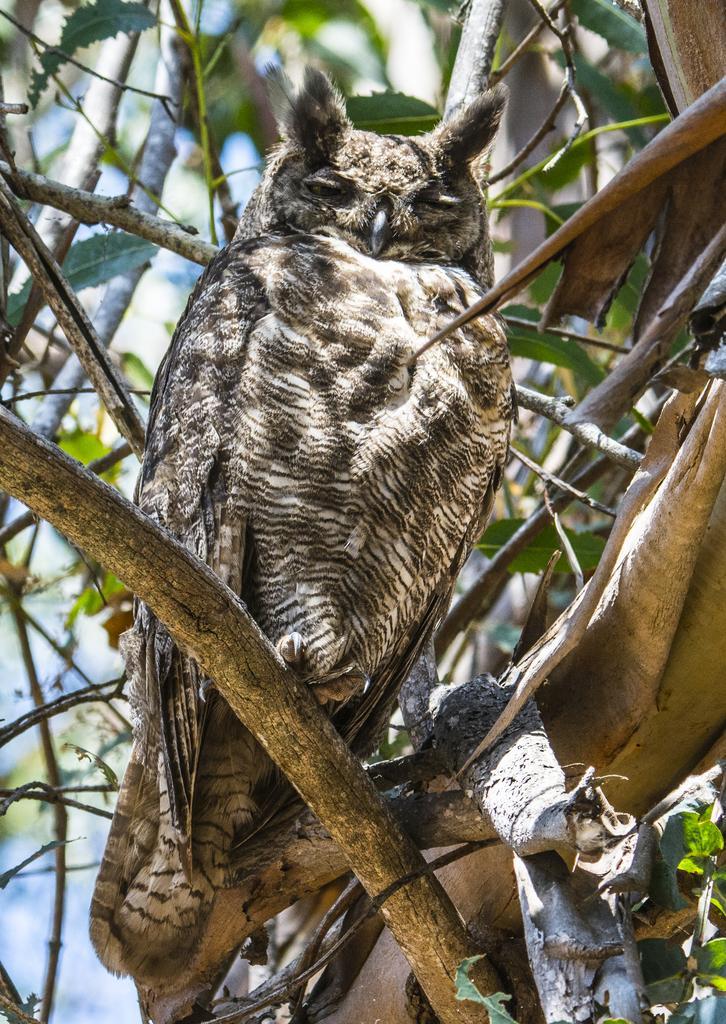In one or two sentences, can you explain what this image depicts? There is an owl on the branch in the foreground area of the image. 